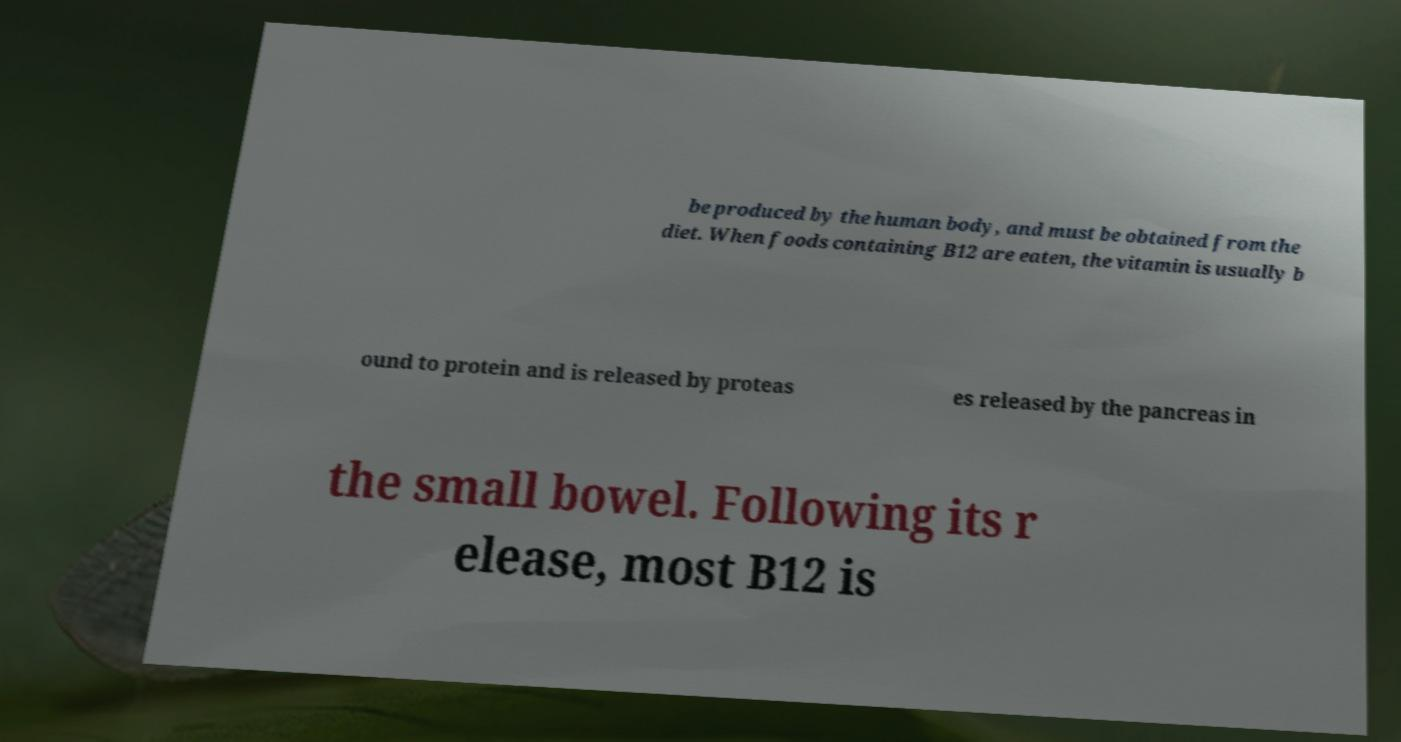Can you accurately transcribe the text from the provided image for me? be produced by the human body, and must be obtained from the diet. When foods containing B12 are eaten, the vitamin is usually b ound to protein and is released by proteas es released by the pancreas in the small bowel. Following its r elease, most B12 is 